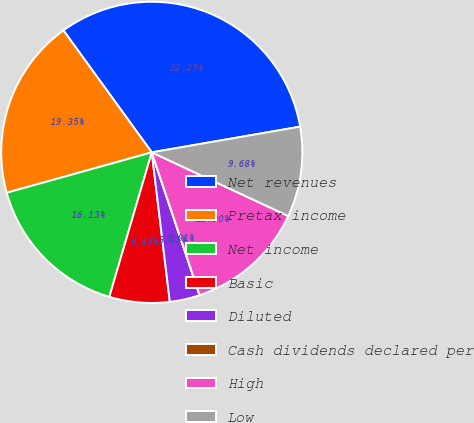Convert chart to OTSL. <chart><loc_0><loc_0><loc_500><loc_500><pie_chart><fcel>Net revenues<fcel>Pretax income<fcel>Net income<fcel>Basic<fcel>Diluted<fcel>Cash dividends declared per<fcel>High<fcel>Low<nl><fcel>32.25%<fcel>19.35%<fcel>16.13%<fcel>6.46%<fcel>3.23%<fcel>0.01%<fcel>12.9%<fcel>9.68%<nl></chart> 